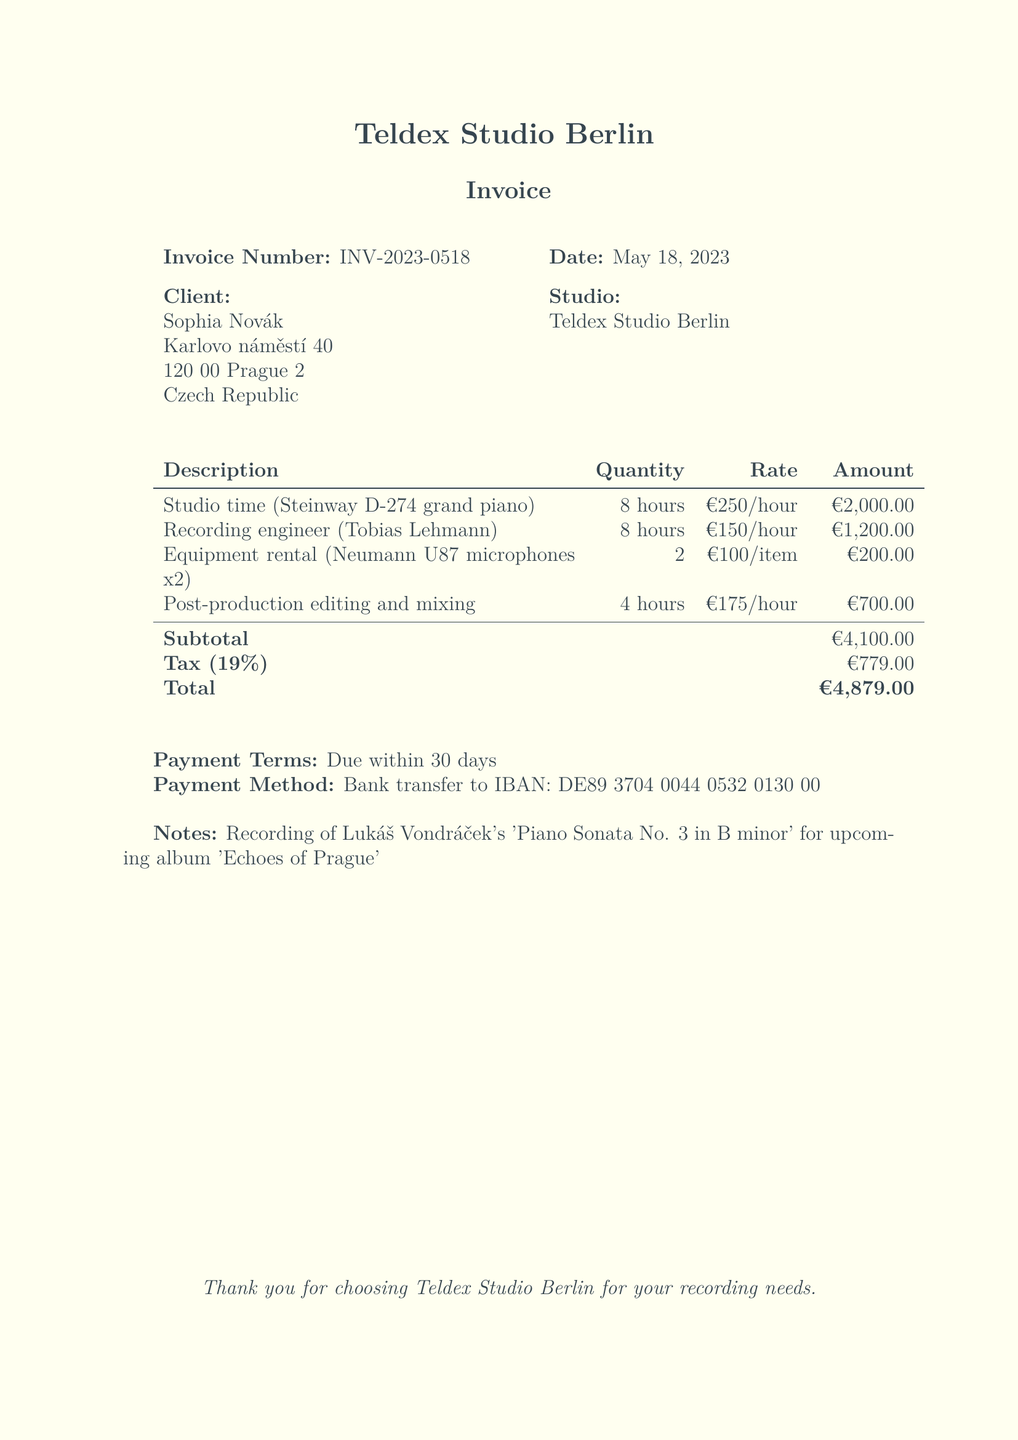What is the invoice number? The invoice number is clearly stated in the document as INV-2023-0518.
Answer: INV-2023-0518 What is the date of the invoice? The date of the invoice is provided under the invoice number section, which is May 18, 2023.
Answer: May 18, 2023 Who is the recording engineer? The name of the recording engineer is listed as Tobias Lehmann.
Answer: Tobias Lehmann What is the subtotal of the invoice? The subtotal is found in the summary of charges and is listed as €4,100.00.
Answer: €4,100.00 What is the total amount due? The total amount due is calculated after taxes and is stated at the bottom as €4,879.00.
Answer: €4,879.00 How many hours of studio time were booked? The document states that 8 hours of studio time were booked for the recording session.
Answer: 8 hours What percentage is the tax on the invoice? The tax percentage noted in the invoice is 19%.
Answer: 19% What equipment was rented for the session? The rented equipment is specified as Neumann U87 microphones, with a quantity of two.
Answer: Neumann U87 microphones x2 What are the payment terms stated in the document? The payment terms indicate that payment is due within 30 days.
Answer: Due within 30 days 